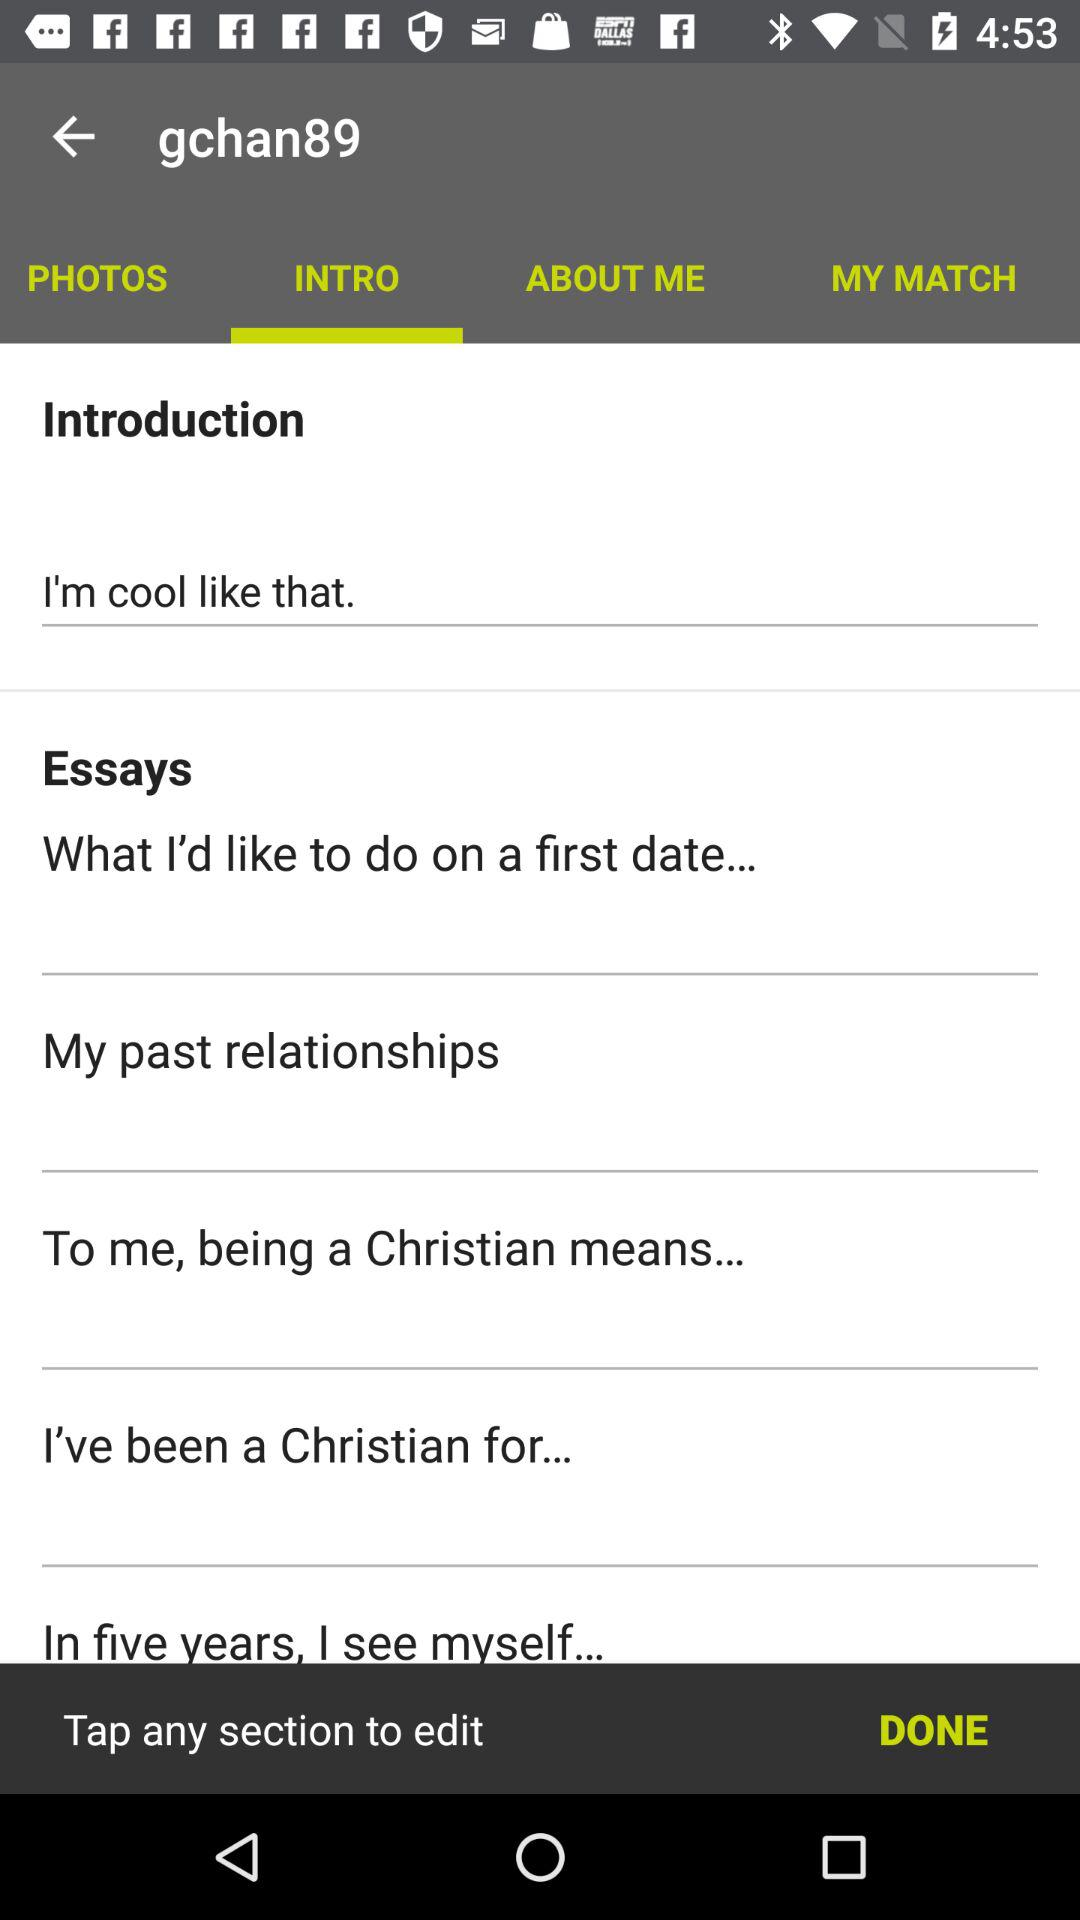Which tab is selected? The selected tab is "INTRO". 